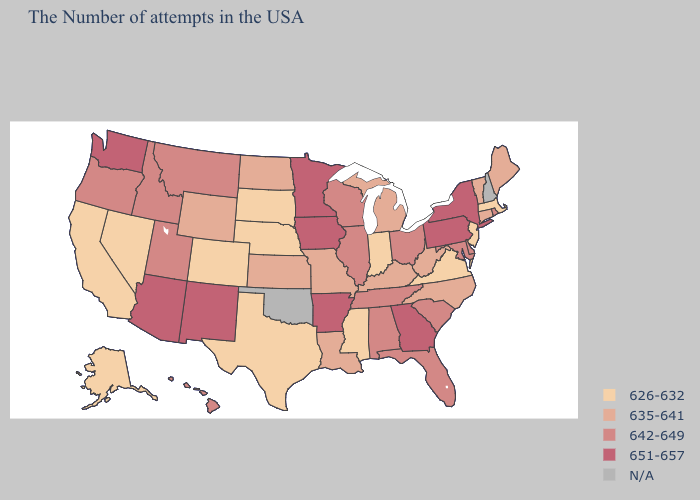Is the legend a continuous bar?
Answer briefly. No. Does New Jersey have the highest value in the Northeast?
Quick response, please. No. Does the first symbol in the legend represent the smallest category?
Keep it brief. Yes. What is the highest value in the South ?
Quick response, please. 651-657. Name the states that have a value in the range 642-649?
Short answer required. Rhode Island, Delaware, Maryland, South Carolina, Ohio, Florida, Alabama, Tennessee, Wisconsin, Illinois, Utah, Montana, Idaho, Oregon, Hawaii. What is the highest value in the USA?
Concise answer only. 651-657. What is the value of Michigan?
Give a very brief answer. 635-641. What is the value of Wyoming?
Keep it brief. 635-641. Among the states that border Ohio , does Pennsylvania have the lowest value?
Give a very brief answer. No. Among the states that border New Jersey , which have the lowest value?
Short answer required. Delaware. How many symbols are there in the legend?
Be succinct. 5. What is the value of Hawaii?
Short answer required. 642-649. Does the map have missing data?
Keep it brief. Yes. 